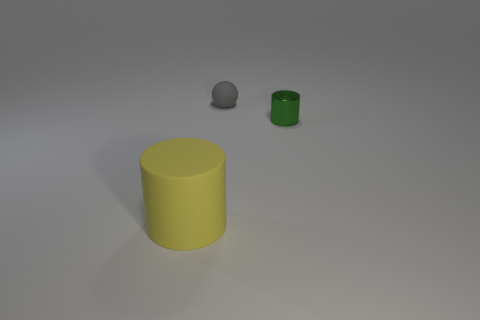How many other metal things have the same shape as the small gray thing?
Ensure brevity in your answer.  0. There is a object behind the cylinder that is behind the cylinder that is left of the tiny ball; how big is it?
Offer a terse response. Small. Does the small thing in front of the gray rubber sphere have the same material as the yellow object?
Offer a terse response. No. Are there an equal number of gray rubber spheres right of the yellow rubber thing and large yellow things that are behind the small gray sphere?
Offer a terse response. No. Is there any other thing that has the same size as the yellow cylinder?
Offer a terse response. No. There is another thing that is the same shape as the large matte thing; what is it made of?
Offer a very short reply. Metal. There is a rubber thing that is behind the cylinder to the right of the large yellow thing; are there any matte cylinders that are behind it?
Provide a succinct answer. No. Do the matte thing that is behind the yellow object and the object on the left side of the rubber ball have the same shape?
Offer a very short reply. No. Are there more cylinders to the right of the gray rubber sphere than gray balls?
Offer a terse response. No. What number of things are either small brown cubes or big rubber things?
Ensure brevity in your answer.  1. 